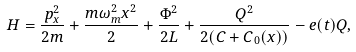<formula> <loc_0><loc_0><loc_500><loc_500>H = \frac { p _ { x } ^ { 2 } } { 2 m } + \frac { m \omega _ { m } ^ { 2 } x ^ { 2 } } { 2 } + \frac { \Phi ^ { 2 } } { 2 L } + \frac { Q ^ { 2 } } { 2 ( C + C _ { 0 } ( x ) ) } - e ( t ) Q ,</formula> 